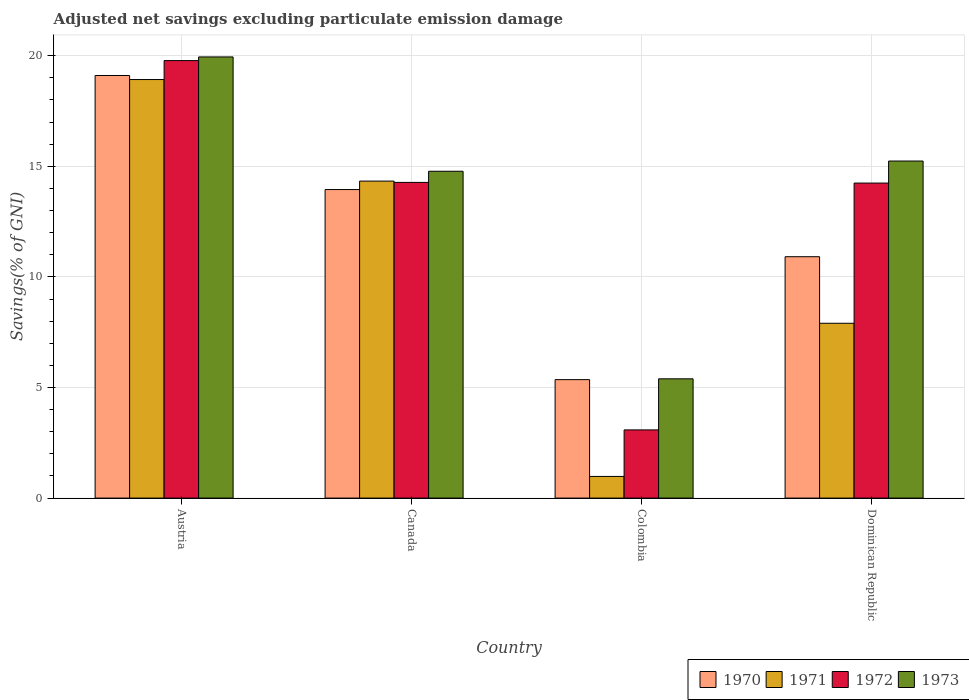How many groups of bars are there?
Your answer should be very brief. 4. How many bars are there on the 4th tick from the left?
Keep it short and to the point. 4. How many bars are there on the 2nd tick from the right?
Your answer should be very brief. 4. In how many cases, is the number of bars for a given country not equal to the number of legend labels?
Make the answer very short. 0. What is the adjusted net savings in 1970 in Colombia?
Your answer should be compact. 5.36. Across all countries, what is the maximum adjusted net savings in 1971?
Keep it short and to the point. 18.92. Across all countries, what is the minimum adjusted net savings in 1973?
Ensure brevity in your answer.  5.39. In which country was the adjusted net savings in 1970 maximum?
Offer a terse response. Austria. In which country was the adjusted net savings in 1973 minimum?
Make the answer very short. Colombia. What is the total adjusted net savings in 1972 in the graph?
Your response must be concise. 51.38. What is the difference between the adjusted net savings in 1970 in Canada and that in Colombia?
Offer a terse response. 8.59. What is the difference between the adjusted net savings in 1972 in Canada and the adjusted net savings in 1973 in Austria?
Ensure brevity in your answer.  -5.67. What is the average adjusted net savings in 1971 per country?
Your response must be concise. 10.53. What is the difference between the adjusted net savings of/in 1970 and adjusted net savings of/in 1973 in Colombia?
Ensure brevity in your answer.  -0.04. In how many countries, is the adjusted net savings in 1970 greater than 16 %?
Make the answer very short. 1. What is the ratio of the adjusted net savings in 1973 in Austria to that in Colombia?
Offer a terse response. 3.7. What is the difference between the highest and the second highest adjusted net savings in 1973?
Offer a very short reply. 5.17. What is the difference between the highest and the lowest adjusted net savings in 1970?
Offer a very short reply. 13.75. In how many countries, is the adjusted net savings in 1971 greater than the average adjusted net savings in 1971 taken over all countries?
Give a very brief answer. 2. Is it the case that in every country, the sum of the adjusted net savings in 1971 and adjusted net savings in 1972 is greater than the sum of adjusted net savings in 1973 and adjusted net savings in 1970?
Your response must be concise. No. What does the 3rd bar from the left in Austria represents?
Give a very brief answer. 1972. How many countries are there in the graph?
Provide a short and direct response. 4. Does the graph contain any zero values?
Offer a very short reply. No. Where does the legend appear in the graph?
Ensure brevity in your answer.  Bottom right. How many legend labels are there?
Offer a terse response. 4. How are the legend labels stacked?
Give a very brief answer. Horizontal. What is the title of the graph?
Make the answer very short. Adjusted net savings excluding particulate emission damage. What is the label or title of the Y-axis?
Ensure brevity in your answer.  Savings(% of GNI). What is the Savings(% of GNI) of 1970 in Austria?
Provide a succinct answer. 19.11. What is the Savings(% of GNI) of 1971 in Austria?
Provide a short and direct response. 18.92. What is the Savings(% of GNI) in 1972 in Austria?
Ensure brevity in your answer.  19.78. What is the Savings(% of GNI) in 1973 in Austria?
Give a very brief answer. 19.94. What is the Savings(% of GNI) in 1970 in Canada?
Your answer should be very brief. 13.95. What is the Savings(% of GNI) in 1971 in Canada?
Your answer should be compact. 14.33. What is the Savings(% of GNI) of 1972 in Canada?
Your answer should be compact. 14.27. What is the Savings(% of GNI) of 1973 in Canada?
Make the answer very short. 14.78. What is the Savings(% of GNI) in 1970 in Colombia?
Your answer should be compact. 5.36. What is the Savings(% of GNI) in 1971 in Colombia?
Your answer should be compact. 0.98. What is the Savings(% of GNI) in 1972 in Colombia?
Your response must be concise. 3.08. What is the Savings(% of GNI) in 1973 in Colombia?
Provide a short and direct response. 5.39. What is the Savings(% of GNI) of 1970 in Dominican Republic?
Make the answer very short. 10.91. What is the Savings(% of GNI) in 1971 in Dominican Republic?
Offer a terse response. 7.9. What is the Savings(% of GNI) of 1972 in Dominican Republic?
Keep it short and to the point. 14.24. What is the Savings(% of GNI) in 1973 in Dominican Republic?
Keep it short and to the point. 15.24. Across all countries, what is the maximum Savings(% of GNI) of 1970?
Your answer should be compact. 19.11. Across all countries, what is the maximum Savings(% of GNI) in 1971?
Give a very brief answer. 18.92. Across all countries, what is the maximum Savings(% of GNI) in 1972?
Offer a terse response. 19.78. Across all countries, what is the maximum Savings(% of GNI) in 1973?
Keep it short and to the point. 19.94. Across all countries, what is the minimum Savings(% of GNI) in 1970?
Your answer should be compact. 5.36. Across all countries, what is the minimum Savings(% of GNI) in 1971?
Provide a succinct answer. 0.98. Across all countries, what is the minimum Savings(% of GNI) in 1972?
Ensure brevity in your answer.  3.08. Across all countries, what is the minimum Savings(% of GNI) of 1973?
Provide a succinct answer. 5.39. What is the total Savings(% of GNI) in 1970 in the graph?
Offer a terse response. 49.32. What is the total Savings(% of GNI) in 1971 in the graph?
Offer a terse response. 42.14. What is the total Savings(% of GNI) in 1972 in the graph?
Give a very brief answer. 51.38. What is the total Savings(% of GNI) of 1973 in the graph?
Provide a succinct answer. 55.35. What is the difference between the Savings(% of GNI) in 1970 in Austria and that in Canada?
Provide a short and direct response. 5.16. What is the difference between the Savings(% of GNI) of 1971 in Austria and that in Canada?
Provide a short and direct response. 4.59. What is the difference between the Savings(% of GNI) of 1972 in Austria and that in Canada?
Your answer should be very brief. 5.51. What is the difference between the Savings(% of GNI) in 1973 in Austria and that in Canada?
Offer a terse response. 5.17. What is the difference between the Savings(% of GNI) of 1970 in Austria and that in Colombia?
Offer a very short reply. 13.75. What is the difference between the Savings(% of GNI) of 1971 in Austria and that in Colombia?
Offer a very short reply. 17.94. What is the difference between the Savings(% of GNI) of 1972 in Austria and that in Colombia?
Keep it short and to the point. 16.7. What is the difference between the Savings(% of GNI) of 1973 in Austria and that in Colombia?
Your answer should be compact. 14.55. What is the difference between the Savings(% of GNI) of 1970 in Austria and that in Dominican Republic?
Your response must be concise. 8.19. What is the difference between the Savings(% of GNI) in 1971 in Austria and that in Dominican Republic?
Provide a succinct answer. 11.02. What is the difference between the Savings(% of GNI) of 1972 in Austria and that in Dominican Republic?
Ensure brevity in your answer.  5.54. What is the difference between the Savings(% of GNI) in 1973 in Austria and that in Dominican Republic?
Ensure brevity in your answer.  4.71. What is the difference between the Savings(% of GNI) of 1970 in Canada and that in Colombia?
Provide a short and direct response. 8.59. What is the difference between the Savings(% of GNI) in 1971 in Canada and that in Colombia?
Offer a terse response. 13.35. What is the difference between the Savings(% of GNI) of 1972 in Canada and that in Colombia?
Your answer should be very brief. 11.19. What is the difference between the Savings(% of GNI) of 1973 in Canada and that in Colombia?
Give a very brief answer. 9.38. What is the difference between the Savings(% of GNI) of 1970 in Canada and that in Dominican Republic?
Offer a terse response. 3.04. What is the difference between the Savings(% of GNI) of 1971 in Canada and that in Dominican Republic?
Your answer should be compact. 6.43. What is the difference between the Savings(% of GNI) of 1972 in Canada and that in Dominican Republic?
Provide a succinct answer. 0.03. What is the difference between the Savings(% of GNI) of 1973 in Canada and that in Dominican Republic?
Your answer should be compact. -0.46. What is the difference between the Savings(% of GNI) of 1970 in Colombia and that in Dominican Republic?
Offer a very short reply. -5.56. What is the difference between the Savings(% of GNI) in 1971 in Colombia and that in Dominican Republic?
Your answer should be compact. -6.92. What is the difference between the Savings(% of GNI) in 1972 in Colombia and that in Dominican Republic?
Give a very brief answer. -11.16. What is the difference between the Savings(% of GNI) in 1973 in Colombia and that in Dominican Republic?
Give a very brief answer. -9.85. What is the difference between the Savings(% of GNI) of 1970 in Austria and the Savings(% of GNI) of 1971 in Canada?
Ensure brevity in your answer.  4.77. What is the difference between the Savings(% of GNI) in 1970 in Austria and the Savings(% of GNI) in 1972 in Canada?
Give a very brief answer. 4.83. What is the difference between the Savings(% of GNI) in 1970 in Austria and the Savings(% of GNI) in 1973 in Canada?
Your answer should be very brief. 4.33. What is the difference between the Savings(% of GNI) of 1971 in Austria and the Savings(% of GNI) of 1972 in Canada?
Keep it short and to the point. 4.65. What is the difference between the Savings(% of GNI) in 1971 in Austria and the Savings(% of GNI) in 1973 in Canada?
Your answer should be very brief. 4.15. What is the difference between the Savings(% of GNI) in 1972 in Austria and the Savings(% of GNI) in 1973 in Canada?
Your answer should be compact. 5. What is the difference between the Savings(% of GNI) in 1970 in Austria and the Savings(% of GNI) in 1971 in Colombia?
Provide a succinct answer. 18.13. What is the difference between the Savings(% of GNI) in 1970 in Austria and the Savings(% of GNI) in 1972 in Colombia?
Make the answer very short. 16.02. What is the difference between the Savings(% of GNI) of 1970 in Austria and the Savings(% of GNI) of 1973 in Colombia?
Offer a terse response. 13.71. What is the difference between the Savings(% of GNI) in 1971 in Austria and the Savings(% of GNI) in 1972 in Colombia?
Provide a succinct answer. 15.84. What is the difference between the Savings(% of GNI) in 1971 in Austria and the Savings(% of GNI) in 1973 in Colombia?
Offer a very short reply. 13.53. What is the difference between the Savings(% of GNI) of 1972 in Austria and the Savings(% of GNI) of 1973 in Colombia?
Provide a short and direct response. 14.39. What is the difference between the Savings(% of GNI) in 1970 in Austria and the Savings(% of GNI) in 1971 in Dominican Republic?
Keep it short and to the point. 11.2. What is the difference between the Savings(% of GNI) of 1970 in Austria and the Savings(% of GNI) of 1972 in Dominican Republic?
Your answer should be very brief. 4.86. What is the difference between the Savings(% of GNI) in 1970 in Austria and the Savings(% of GNI) in 1973 in Dominican Republic?
Keep it short and to the point. 3.87. What is the difference between the Savings(% of GNI) of 1971 in Austria and the Savings(% of GNI) of 1972 in Dominican Republic?
Offer a terse response. 4.68. What is the difference between the Savings(% of GNI) in 1971 in Austria and the Savings(% of GNI) in 1973 in Dominican Republic?
Provide a succinct answer. 3.68. What is the difference between the Savings(% of GNI) of 1972 in Austria and the Savings(% of GNI) of 1973 in Dominican Republic?
Make the answer very short. 4.54. What is the difference between the Savings(% of GNI) of 1970 in Canada and the Savings(% of GNI) of 1971 in Colombia?
Provide a succinct answer. 12.97. What is the difference between the Savings(% of GNI) in 1970 in Canada and the Savings(% of GNI) in 1972 in Colombia?
Provide a succinct answer. 10.87. What is the difference between the Savings(% of GNI) in 1970 in Canada and the Savings(% of GNI) in 1973 in Colombia?
Give a very brief answer. 8.56. What is the difference between the Savings(% of GNI) of 1971 in Canada and the Savings(% of GNI) of 1972 in Colombia?
Give a very brief answer. 11.25. What is the difference between the Savings(% of GNI) of 1971 in Canada and the Savings(% of GNI) of 1973 in Colombia?
Ensure brevity in your answer.  8.94. What is the difference between the Savings(% of GNI) in 1972 in Canada and the Savings(% of GNI) in 1973 in Colombia?
Offer a very short reply. 8.88. What is the difference between the Savings(% of GNI) in 1970 in Canada and the Savings(% of GNI) in 1971 in Dominican Republic?
Provide a succinct answer. 6.05. What is the difference between the Savings(% of GNI) in 1970 in Canada and the Savings(% of GNI) in 1972 in Dominican Republic?
Your answer should be very brief. -0.29. What is the difference between the Savings(% of GNI) in 1970 in Canada and the Savings(% of GNI) in 1973 in Dominican Republic?
Offer a terse response. -1.29. What is the difference between the Savings(% of GNI) in 1971 in Canada and the Savings(% of GNI) in 1972 in Dominican Republic?
Ensure brevity in your answer.  0.09. What is the difference between the Savings(% of GNI) of 1971 in Canada and the Savings(% of GNI) of 1973 in Dominican Republic?
Offer a terse response. -0.91. What is the difference between the Savings(% of GNI) of 1972 in Canada and the Savings(% of GNI) of 1973 in Dominican Republic?
Keep it short and to the point. -0.97. What is the difference between the Savings(% of GNI) in 1970 in Colombia and the Savings(% of GNI) in 1971 in Dominican Republic?
Your answer should be compact. -2.55. What is the difference between the Savings(% of GNI) of 1970 in Colombia and the Savings(% of GNI) of 1972 in Dominican Republic?
Your answer should be compact. -8.89. What is the difference between the Savings(% of GNI) of 1970 in Colombia and the Savings(% of GNI) of 1973 in Dominican Republic?
Ensure brevity in your answer.  -9.88. What is the difference between the Savings(% of GNI) in 1971 in Colombia and the Savings(% of GNI) in 1972 in Dominican Republic?
Provide a succinct answer. -13.26. What is the difference between the Savings(% of GNI) in 1971 in Colombia and the Savings(% of GNI) in 1973 in Dominican Republic?
Provide a succinct answer. -14.26. What is the difference between the Savings(% of GNI) of 1972 in Colombia and the Savings(% of GNI) of 1973 in Dominican Republic?
Offer a terse response. -12.15. What is the average Savings(% of GNI) of 1970 per country?
Ensure brevity in your answer.  12.33. What is the average Savings(% of GNI) in 1971 per country?
Make the answer very short. 10.53. What is the average Savings(% of GNI) in 1972 per country?
Keep it short and to the point. 12.84. What is the average Savings(% of GNI) in 1973 per country?
Your answer should be compact. 13.84. What is the difference between the Savings(% of GNI) in 1970 and Savings(% of GNI) in 1971 in Austria?
Your answer should be compact. 0.18. What is the difference between the Savings(% of GNI) in 1970 and Savings(% of GNI) in 1972 in Austria?
Your response must be concise. -0.67. What is the difference between the Savings(% of GNI) of 1970 and Savings(% of GNI) of 1973 in Austria?
Provide a succinct answer. -0.84. What is the difference between the Savings(% of GNI) of 1971 and Savings(% of GNI) of 1972 in Austria?
Give a very brief answer. -0.86. What is the difference between the Savings(% of GNI) of 1971 and Savings(% of GNI) of 1973 in Austria?
Offer a very short reply. -1.02. What is the difference between the Savings(% of GNI) of 1972 and Savings(% of GNI) of 1973 in Austria?
Provide a short and direct response. -0.17. What is the difference between the Savings(% of GNI) of 1970 and Savings(% of GNI) of 1971 in Canada?
Ensure brevity in your answer.  -0.38. What is the difference between the Savings(% of GNI) in 1970 and Savings(% of GNI) in 1972 in Canada?
Provide a short and direct response. -0.32. What is the difference between the Savings(% of GNI) of 1970 and Savings(% of GNI) of 1973 in Canada?
Offer a very short reply. -0.83. What is the difference between the Savings(% of GNI) of 1971 and Savings(% of GNI) of 1972 in Canada?
Provide a short and direct response. 0.06. What is the difference between the Savings(% of GNI) of 1971 and Savings(% of GNI) of 1973 in Canada?
Ensure brevity in your answer.  -0.45. What is the difference between the Savings(% of GNI) of 1972 and Savings(% of GNI) of 1973 in Canada?
Ensure brevity in your answer.  -0.5. What is the difference between the Savings(% of GNI) of 1970 and Savings(% of GNI) of 1971 in Colombia?
Provide a short and direct response. 4.38. What is the difference between the Savings(% of GNI) of 1970 and Savings(% of GNI) of 1972 in Colombia?
Offer a terse response. 2.27. What is the difference between the Savings(% of GNI) of 1970 and Savings(% of GNI) of 1973 in Colombia?
Your answer should be very brief. -0.04. What is the difference between the Savings(% of GNI) of 1971 and Savings(% of GNI) of 1972 in Colombia?
Your response must be concise. -2.1. What is the difference between the Savings(% of GNI) in 1971 and Savings(% of GNI) in 1973 in Colombia?
Offer a very short reply. -4.41. What is the difference between the Savings(% of GNI) of 1972 and Savings(% of GNI) of 1973 in Colombia?
Keep it short and to the point. -2.31. What is the difference between the Savings(% of GNI) in 1970 and Savings(% of GNI) in 1971 in Dominican Republic?
Provide a short and direct response. 3.01. What is the difference between the Savings(% of GNI) of 1970 and Savings(% of GNI) of 1972 in Dominican Republic?
Your response must be concise. -3.33. What is the difference between the Savings(% of GNI) in 1970 and Savings(% of GNI) in 1973 in Dominican Republic?
Offer a terse response. -4.33. What is the difference between the Savings(% of GNI) in 1971 and Savings(% of GNI) in 1972 in Dominican Republic?
Make the answer very short. -6.34. What is the difference between the Savings(% of GNI) in 1971 and Savings(% of GNI) in 1973 in Dominican Republic?
Offer a terse response. -7.33. What is the difference between the Savings(% of GNI) in 1972 and Savings(% of GNI) in 1973 in Dominican Republic?
Your answer should be very brief. -1. What is the ratio of the Savings(% of GNI) of 1970 in Austria to that in Canada?
Give a very brief answer. 1.37. What is the ratio of the Savings(% of GNI) of 1971 in Austria to that in Canada?
Make the answer very short. 1.32. What is the ratio of the Savings(% of GNI) of 1972 in Austria to that in Canada?
Your answer should be very brief. 1.39. What is the ratio of the Savings(% of GNI) of 1973 in Austria to that in Canada?
Your answer should be compact. 1.35. What is the ratio of the Savings(% of GNI) of 1970 in Austria to that in Colombia?
Provide a short and direct response. 3.57. What is the ratio of the Savings(% of GNI) of 1971 in Austria to that in Colombia?
Provide a short and direct response. 19.32. What is the ratio of the Savings(% of GNI) in 1972 in Austria to that in Colombia?
Ensure brevity in your answer.  6.42. What is the ratio of the Savings(% of GNI) in 1973 in Austria to that in Colombia?
Your answer should be compact. 3.7. What is the ratio of the Savings(% of GNI) in 1970 in Austria to that in Dominican Republic?
Your response must be concise. 1.75. What is the ratio of the Savings(% of GNI) of 1971 in Austria to that in Dominican Republic?
Offer a terse response. 2.39. What is the ratio of the Savings(% of GNI) in 1972 in Austria to that in Dominican Republic?
Offer a terse response. 1.39. What is the ratio of the Savings(% of GNI) in 1973 in Austria to that in Dominican Republic?
Keep it short and to the point. 1.31. What is the ratio of the Savings(% of GNI) of 1970 in Canada to that in Colombia?
Offer a very short reply. 2.6. What is the ratio of the Savings(% of GNI) of 1971 in Canada to that in Colombia?
Offer a very short reply. 14.64. What is the ratio of the Savings(% of GNI) of 1972 in Canada to that in Colombia?
Offer a terse response. 4.63. What is the ratio of the Savings(% of GNI) in 1973 in Canada to that in Colombia?
Your answer should be compact. 2.74. What is the ratio of the Savings(% of GNI) of 1970 in Canada to that in Dominican Republic?
Your answer should be very brief. 1.28. What is the ratio of the Savings(% of GNI) in 1971 in Canada to that in Dominican Republic?
Offer a terse response. 1.81. What is the ratio of the Savings(% of GNI) in 1972 in Canada to that in Dominican Republic?
Make the answer very short. 1. What is the ratio of the Savings(% of GNI) in 1973 in Canada to that in Dominican Republic?
Keep it short and to the point. 0.97. What is the ratio of the Savings(% of GNI) of 1970 in Colombia to that in Dominican Republic?
Keep it short and to the point. 0.49. What is the ratio of the Savings(% of GNI) in 1971 in Colombia to that in Dominican Republic?
Keep it short and to the point. 0.12. What is the ratio of the Savings(% of GNI) in 1972 in Colombia to that in Dominican Republic?
Offer a terse response. 0.22. What is the ratio of the Savings(% of GNI) in 1973 in Colombia to that in Dominican Republic?
Your answer should be very brief. 0.35. What is the difference between the highest and the second highest Savings(% of GNI) in 1970?
Provide a short and direct response. 5.16. What is the difference between the highest and the second highest Savings(% of GNI) of 1971?
Offer a very short reply. 4.59. What is the difference between the highest and the second highest Savings(% of GNI) in 1972?
Make the answer very short. 5.51. What is the difference between the highest and the second highest Savings(% of GNI) in 1973?
Your answer should be very brief. 4.71. What is the difference between the highest and the lowest Savings(% of GNI) of 1970?
Provide a succinct answer. 13.75. What is the difference between the highest and the lowest Savings(% of GNI) in 1971?
Keep it short and to the point. 17.94. What is the difference between the highest and the lowest Savings(% of GNI) of 1972?
Offer a terse response. 16.7. What is the difference between the highest and the lowest Savings(% of GNI) of 1973?
Give a very brief answer. 14.55. 